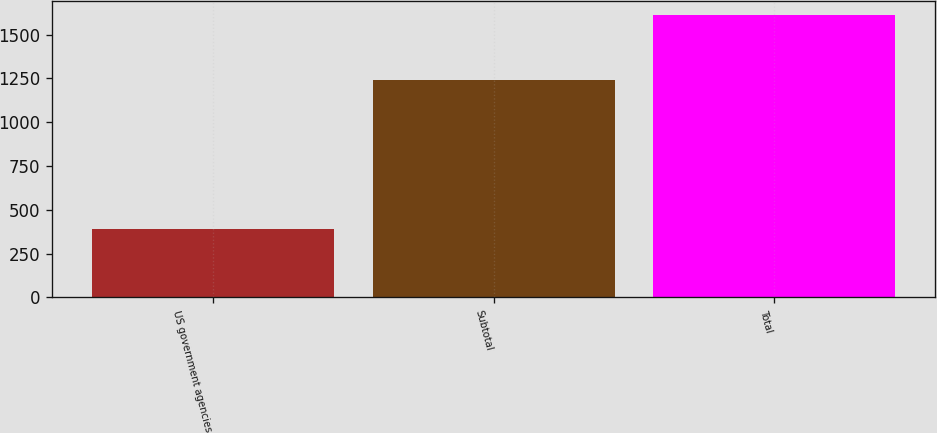Convert chart. <chart><loc_0><loc_0><loc_500><loc_500><bar_chart><fcel>US government agencies<fcel>Subtotal<fcel>Total<nl><fcel>389<fcel>1239.9<fcel>1610<nl></chart> 